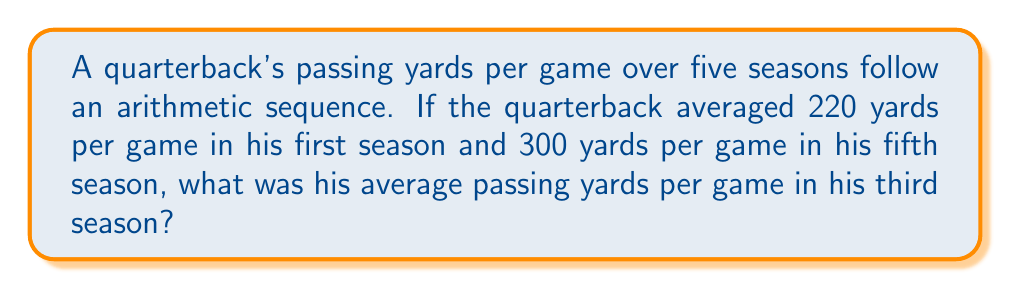What is the answer to this math problem? Let's approach this step-by-step:

1) In an arithmetic sequence, the difference between each term is constant. Let's call this common difference $d$.

2) We know the first term $a_1 = 220$ and the fifth term $a_5 = 300$.

3) In an arithmetic sequence, the nth term is given by:
   $a_n = a_1 + (n-1)d$

4) Using this formula for the fifth term:
   $300 = 220 + (5-1)d$
   $300 = 220 + 4d$

5) Solving for $d$:
   $80 = 4d$
   $d = 20$

6) Now that we know the common difference, we can find the third term using the same formula:
   $a_3 = a_1 + (3-1)d$
   $a_3 = 220 + (2)(20)$
   $a_3 = 220 + 40$
   $a_3 = 260$

Therefore, in his third season, the quarterback averaged 260 yards per game.
Answer: 260 yards per game 